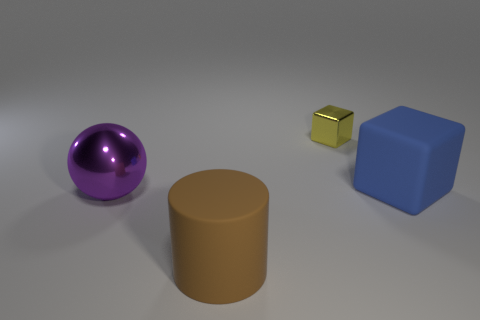How many things are behind the large purple shiny sphere and in front of the tiny shiny cube?
Ensure brevity in your answer.  1. What number of other things are the same shape as the large purple metallic object?
Keep it short and to the point. 0. Are there more big purple metal balls on the right side of the small shiny cube than blue rubber objects?
Ensure brevity in your answer.  No. The metal thing in front of the large blue matte thing is what color?
Your response must be concise. Purple. How many metallic objects are either big blue things or cyan cylinders?
Provide a short and direct response. 0. Is there a yellow object that is in front of the large brown rubber object in front of the big rubber object behind the purple metal sphere?
Provide a succinct answer. No. What number of large rubber objects are to the right of the small shiny thing?
Provide a succinct answer. 1. What number of big things are blue shiny balls or metal spheres?
Give a very brief answer. 1. What is the shape of the rubber thing that is behind the brown thing?
Your answer should be very brief. Cube. Are there any tiny shiny blocks of the same color as the rubber cylinder?
Provide a succinct answer. No. 